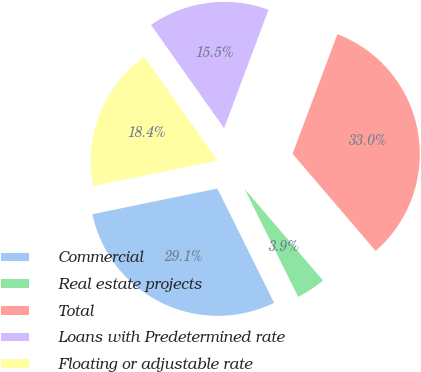Convert chart. <chart><loc_0><loc_0><loc_500><loc_500><pie_chart><fcel>Commercial<fcel>Real estate projects<fcel>Total<fcel>Loans with Predetermined rate<fcel>Floating or adjustable rate<nl><fcel>29.11%<fcel>3.93%<fcel>33.03%<fcel>15.51%<fcel>18.42%<nl></chart> 